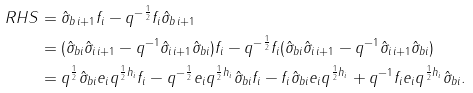Convert formula to latex. <formula><loc_0><loc_0><loc_500><loc_500>R H S & = \hat { \sigma } _ { b \, i + 1 } f _ { i } - q ^ { - \frac { 1 } { 2 } } f _ { i } \hat { \sigma } _ { b \, i + 1 } \\ & = ( \hat { \sigma } _ { b i } \hat { \sigma } _ { i \, i + 1 } - q ^ { - 1 } \hat { \sigma } _ { i \, i + 1 } \hat { \sigma } _ { b i } ) f _ { i } - q ^ { - \frac { 1 } { 2 } } f _ { i } ( \hat { \sigma } _ { b i } \hat { \sigma } _ { i \, i + 1 } - q ^ { - 1 } \hat { \sigma } _ { i \, i + 1 } \hat { \sigma } _ { b i } ) \\ & = q ^ { \frac { 1 } { 2 } } \hat { \sigma } _ { b i } e _ { i } q ^ { \frac { 1 } { 2 } h _ { i } } f _ { i } - q ^ { - \frac { 1 } { 2 } } e _ { i } q ^ { \frac { 1 } { 2 } h _ { i } } \hat { \sigma } _ { b i } f _ { i } - f _ { i } \hat { \sigma } _ { b i } e _ { i } q ^ { \frac { 1 } { 2 } h _ { i } } + q ^ { - 1 } f _ { i } e _ { i } q ^ { \frac { 1 } { 2 } h _ { i } } \hat { \sigma } _ { b i } .</formula> 